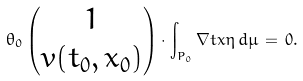<formula> <loc_0><loc_0><loc_500><loc_500>\theta _ { 0 } \begin{pmatrix} 1 \\ v ( t _ { 0 } , x _ { 0 } ) \end{pmatrix} \cdot \int _ { P _ { 0 } } \nabla t x \eta \, d \mu \, = \, 0 .</formula> 